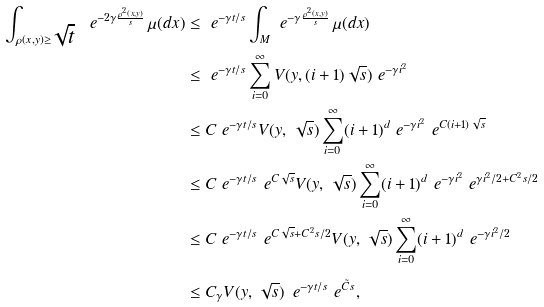<formula> <loc_0><loc_0><loc_500><loc_500>\int _ { \rho ( x , y ) \geq \sqrt { t } } \ e ^ { - 2 \gamma \frac { \rho ^ { 2 } ( x , y ) } { s } } \, \mu ( d x ) & \leq \ e ^ { - \gamma t / s } \int _ { M } \ e ^ { - \gamma \frac { \rho ^ { 2 } ( x , y ) } { s } } \, \mu ( d x ) \\ & \leq \ e ^ { - \gamma t / s } \sum _ { i = 0 } ^ { \infty } V ( y , ( i + 1 ) \sqrt { s } ) \ e ^ { - \gamma i ^ { 2 } } \\ & \leq C \ e ^ { - \gamma t / s } V ( y , \, \sqrt { s } ) \sum _ { i = 0 } ^ { \infty } ( i + 1 ) ^ { d } \ e ^ { - \gamma i ^ { 2 } } \ e ^ { C ( i + 1 ) \sqrt { s } } \\ & \leq C \ e ^ { - \gamma t / s } \ e ^ { C \sqrt { s } } V ( y , \, \sqrt { s } ) \sum _ { i = 0 } ^ { \infty } ( i + 1 ) ^ { d } \ e ^ { - \gamma i ^ { 2 } } \ e ^ { \gamma i ^ { 2 } / 2 + C ^ { 2 } s / 2 } \\ & \leq C \ e ^ { - \gamma t / s } \ e ^ { C \sqrt { s } + C ^ { 2 } s / 2 } V ( y , \, \sqrt { s } ) \sum _ { i = 0 } ^ { \infty } ( i + 1 ) ^ { d } \ e ^ { - \gamma i ^ { 2 } / 2 } \\ & \leq C _ { \gamma } V ( y , \, \sqrt { s } ) \, \ e ^ { - \gamma t / s } \ e ^ { \tilde { C } s } ,</formula> 